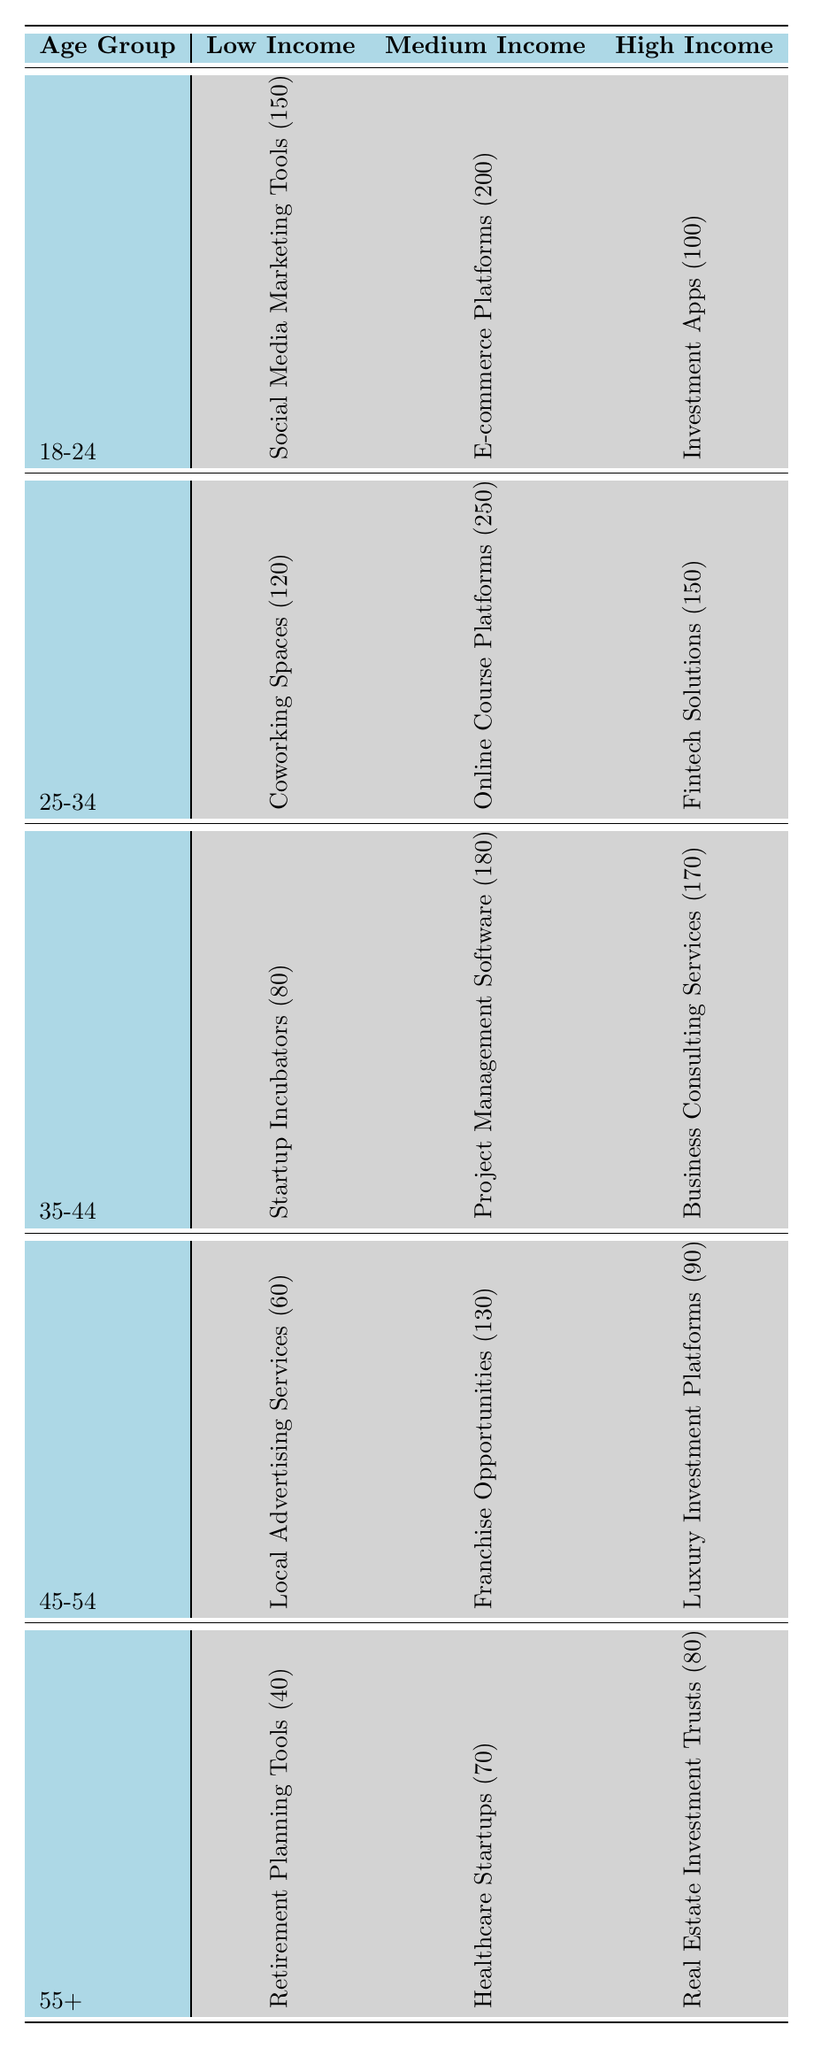What is the preferred product for the age group 18-24 with high income? The table shows that for the age group 18-24 in the high income category, the preferred product is Investment Apps with a preference count of 100.
Answer: Investment Apps What is the preference count for Healthcare Startups among the 55+ age group? According to the table, for the age group 55+ in the medium income category, the preferred product is Healthcare Startups, which has a preference count of 70.
Answer: 70 Which income level has the highest preference count for the age group 25-34? For the age group 25-34, the medium income level has the highest count with Online Course Platforms at 250, compared to 120 and 150 in low and high income levels, respectively.
Answer: Medium Income Is there a preferred product for the age group 45-54 with low income? Yes, there is a preferred product for the age group 45-54 with low income, which is Local Advertising Services with a preference count of 60.
Answer: Yes What is the total preference count for all age groups in the low income category? To find the total preference count for low income, we sum the counts: 150 (18-24) + 120 (25-34) + 80 (35-44) + 60 (45-54) + 40 (55+) = 450.
Answer: 450 What is the average preference count for the medium income level across all age groups? The medium income products have counts of 200 (18-24), 250 (25-34), 180 (35-44), 130 (45-54), and 70 (55+). The total is 200 + 250 + 180 + 130 + 70 = 830. There are 5 age groups, so the average is 830/5 = 166.
Answer: 166 Which product has the lowest preference count in the low income category? The table indicates that among low income preferences, Retirement Planning Tools for the 55+ age group has the lowest preference count of 40.
Answer: Retirement Planning Tools Is the total preference count for high income greater than that for low income across all age groups? To answer, we sum the high income counts: 100 (18-24) + 150 (25-34) + 170 (35-44) + 90 (45-54) + 80 (55+) = 590. For low income, the total is 450. Since 590 > 450, the statement is true.
Answer: Yes Which age group had the highest overall preference count for entrepreneurial products? By adding all the preference counts for each age group, we get: 150 + 200 + 100 (18-24) = 450, 120 + 250 + 150 (25-34) = 520, 80 + 180 + 170 (35-44) = 430, 60 + 130 + 90 (45-54) = 280, 40 + 70 + 80 (55+) = 190. The age group 25-34 has the highest count of 520.
Answer: 25-34 